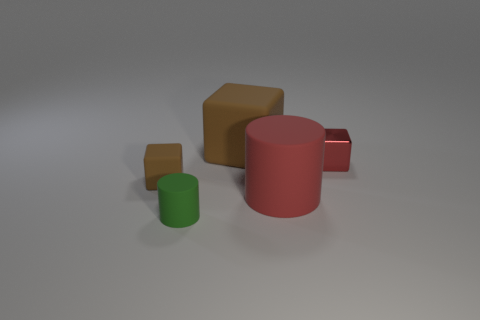Can you describe the lighting and shadows visible in the scene? The lighting in the scene appears to come from the upper left, casting subtle shadows towards the right. These shadows help accentuate the forms of the objects and provide a sense of depth and dimensionality to the composition. 